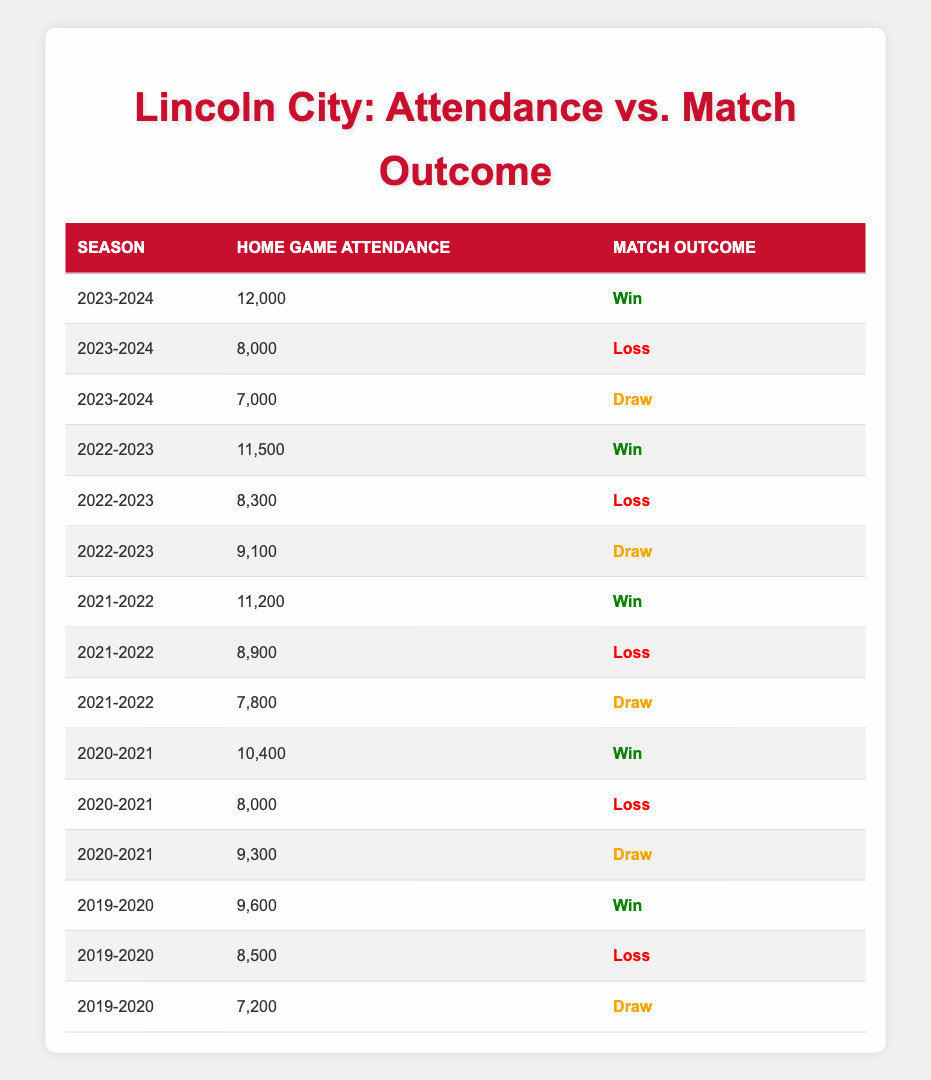What was the home game attendance during the 2022-2023 season when Lincoln City won? In the 2022-2023 season, Lincoln City had a home game attendance of 11,500 when they won the match. This information can be found directly from the 'Match Outcome' column for that specific season.
Answer: 11,500 How many matches did Lincoln City lose at home during the 2021-2022 season? During the 2021-2022 season, there were two instances of match losses recorded: one with a home game attendance of 8,900 and another at 7,800. Hence, Lincoln City lost 2 matches that season.
Answer: 2 What is the average home game attendance for the seasons where Lincoln City drew? The draw matches occurred with attendances of 7,200 (2019-2020), 9,300 (2020-2021), 7,800 (2021-2022), 9,100 (2022-2023), and 7,000 (2023-2024). First, we sum them up: 7,200 + 9,300 + 7,800 + 9,100 + 7,000 = 40,400. There are 5 draw matches, so the average is 40,400 / 5 = 8,080.
Answer: 8,080 Was there a season where Lincoln City had 10,400 or more in home game attendance and lost the match? Yes, there was a season (2020-2021) where Lincoln City had a home game attendance of 10,400, and they lost the match in another instance with 8,000 attendance. Therefore, the answer is true.
Answer: Yes Which match outcome occurred most frequently during the 2019-2020 season? In the 2019-2020 season, there were three matches: one win (attendance: 9,600), one loss (attendance: 8,500), and one draw (attendance: 7,200). The match outcomes are equally represented, so there's no predominant outcome.
Answer: None What is the difference in home game attendance between the highest and lowest for the 2023-2024 season? For the 2023-2024 season, the highest attendance was 12,000 and the lowest was 7,000. The difference is calculated as 12,000 - 7,000 = 5,000.
Answer: 5,000 How does the attendance correlate with match outcomes based on the data? Analyzing the table, it shows that higher attendances often correspond to wins (e.g., 12,000, 11,500, and 11,200 all resulted in wins), while lower attendances tend to correspond with losses (e.g., 8,000). Thus, a positive correlation is observed.
Answer: Positive correlation Did Lincoln City achieve better match outcomes with increasing attendances over the five seasons? Yes, as the home game attendance tends to increase, there is a clear trend where the instances of wins increase alongside the attendances, suggesting performance improves with better support.
Answer: Yes 